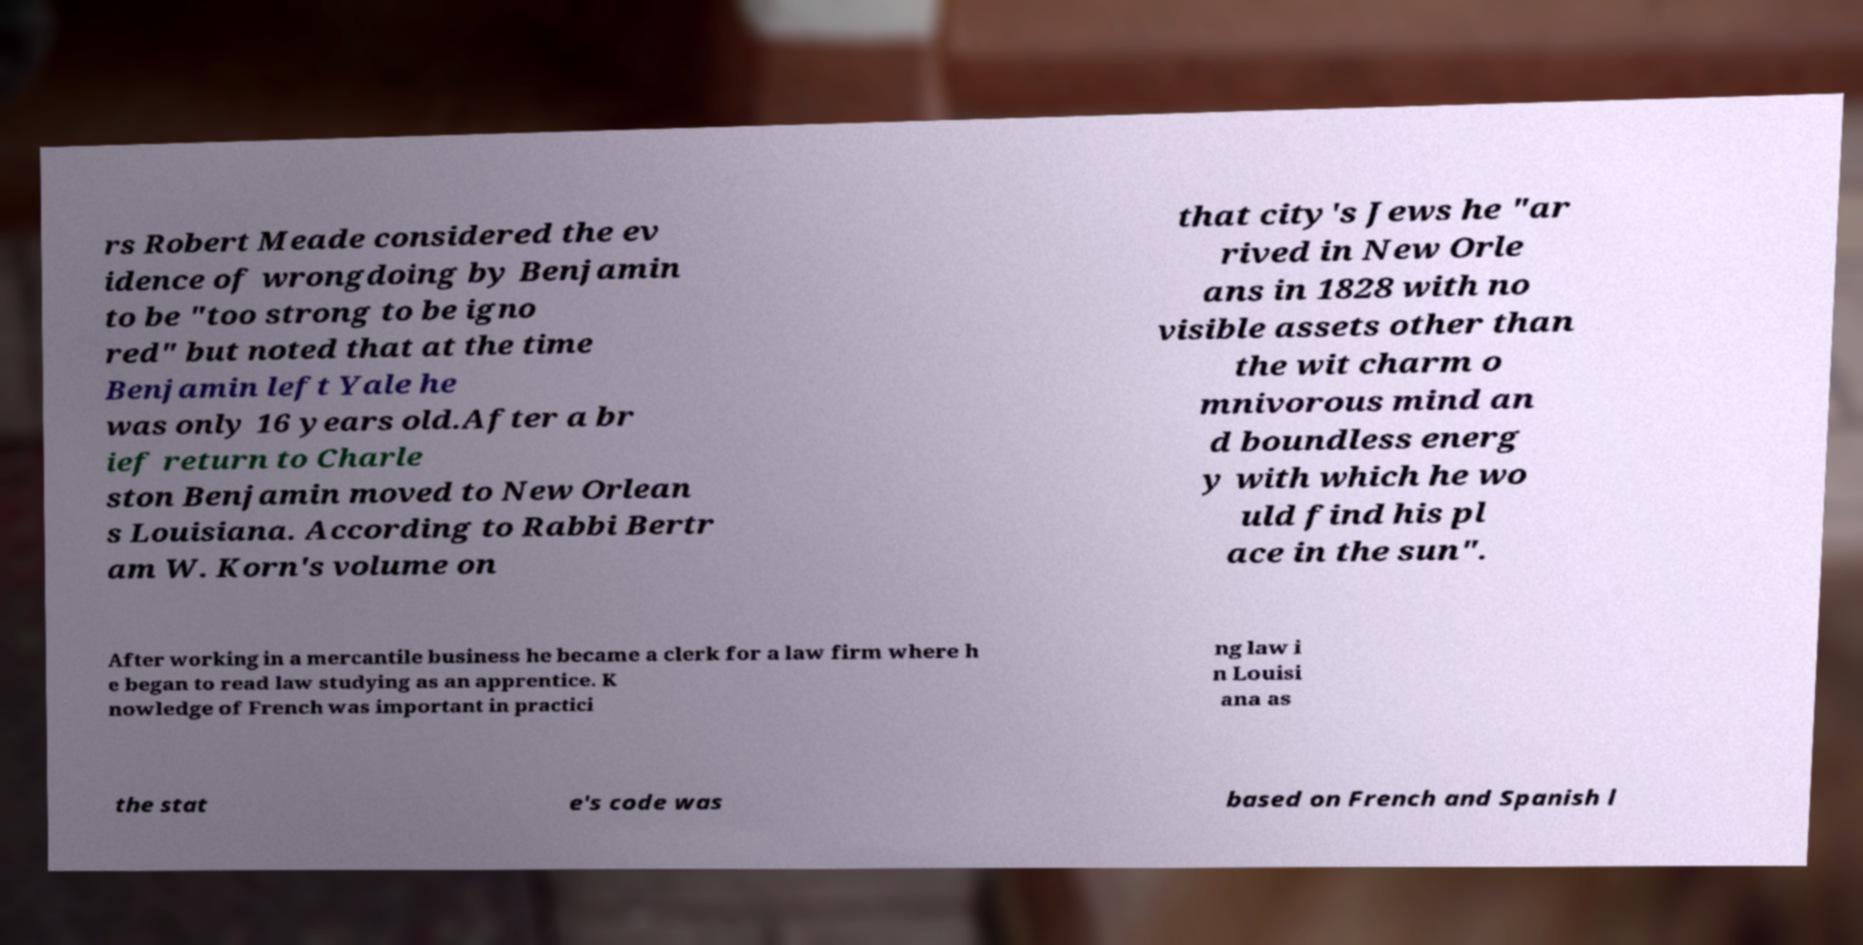Please identify and transcribe the text found in this image. rs Robert Meade considered the ev idence of wrongdoing by Benjamin to be "too strong to be igno red" but noted that at the time Benjamin left Yale he was only 16 years old.After a br ief return to Charle ston Benjamin moved to New Orlean s Louisiana. According to Rabbi Bertr am W. Korn's volume on that city's Jews he "ar rived in New Orle ans in 1828 with no visible assets other than the wit charm o mnivorous mind an d boundless energ y with which he wo uld find his pl ace in the sun". After working in a mercantile business he became a clerk for a law firm where h e began to read law studying as an apprentice. K nowledge of French was important in practici ng law i n Louisi ana as the stat e's code was based on French and Spanish l 